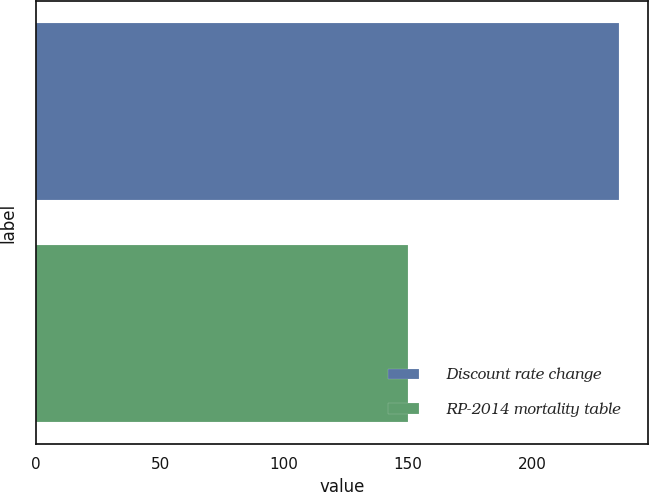<chart> <loc_0><loc_0><loc_500><loc_500><bar_chart><fcel>Discount rate change<fcel>RP-2014 mortality table<nl><fcel>235<fcel>150<nl></chart> 